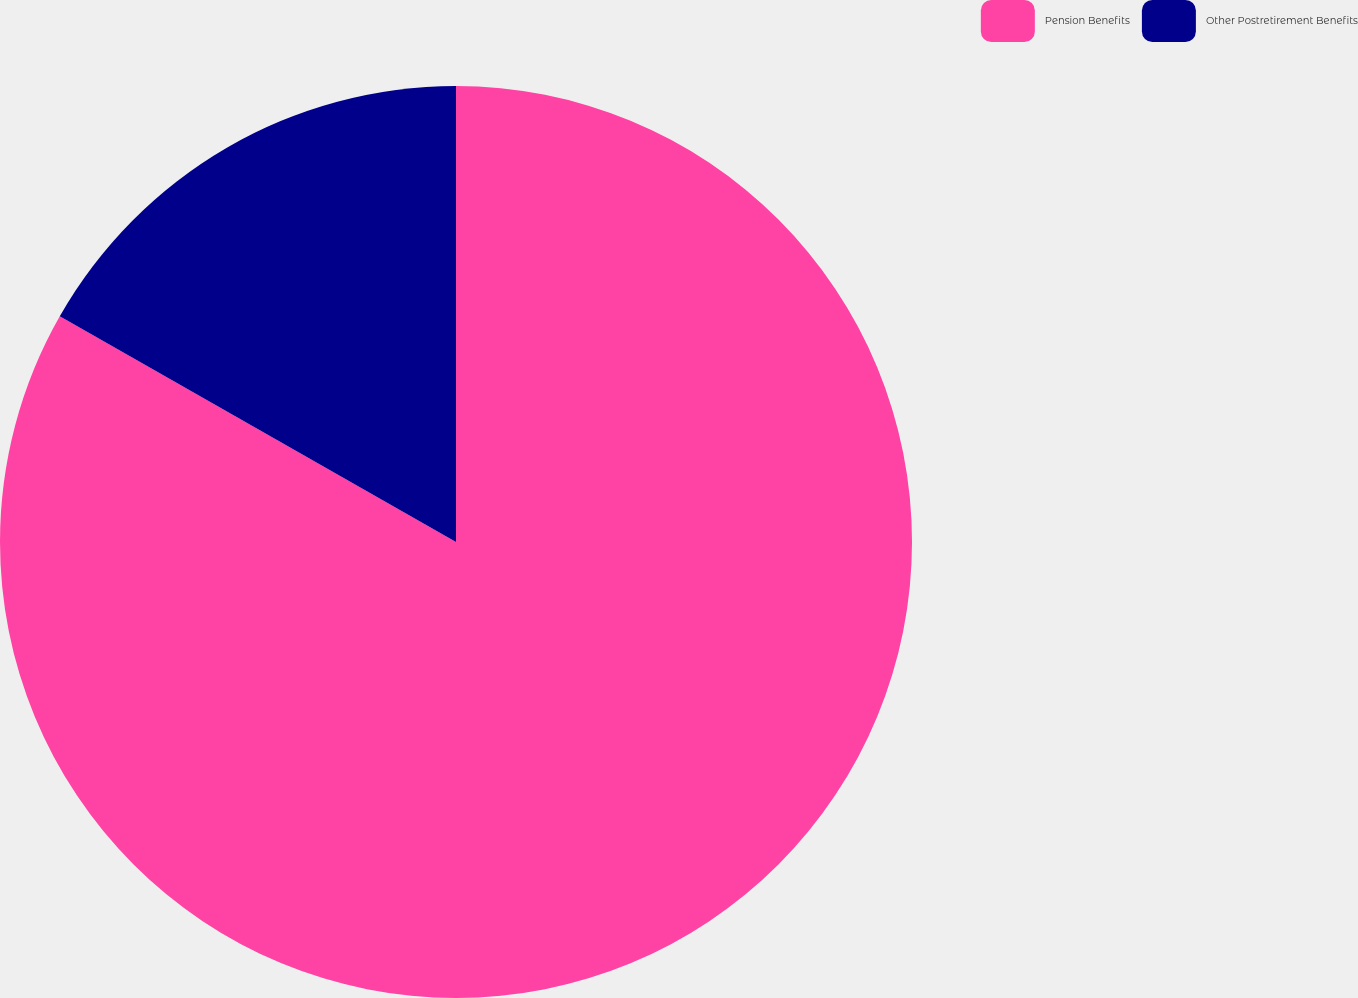Convert chart. <chart><loc_0><loc_0><loc_500><loc_500><pie_chart><fcel>Pension Benefits<fcel>Other Postretirement Benefits<nl><fcel>83.24%<fcel>16.76%<nl></chart> 